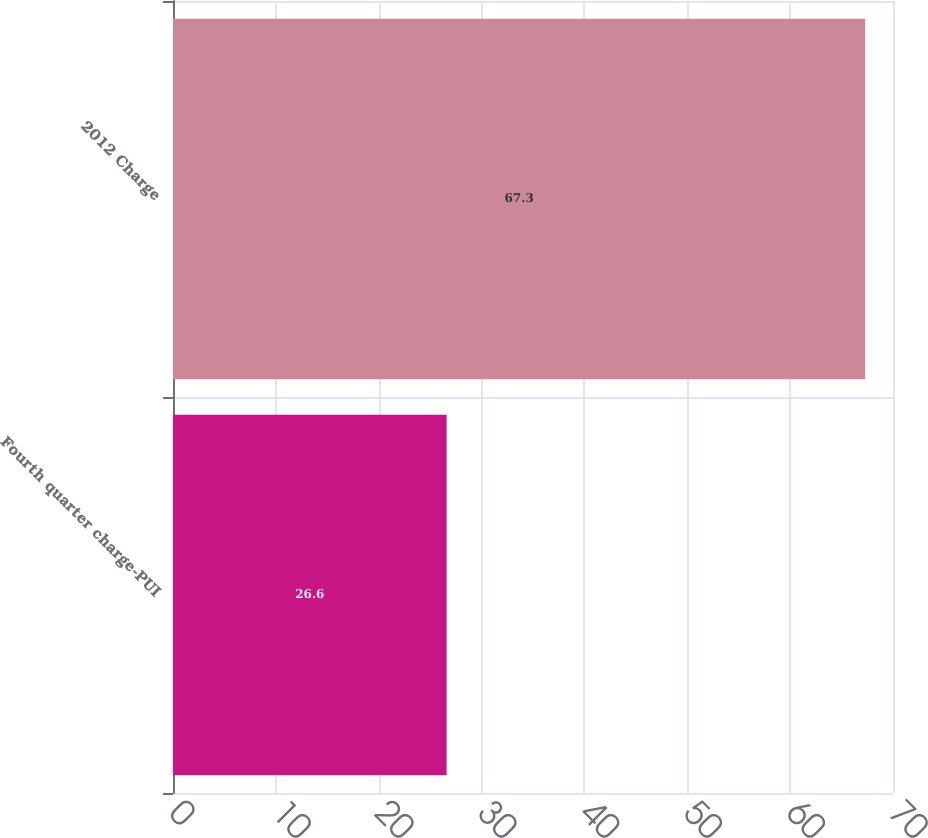<chart> <loc_0><loc_0><loc_500><loc_500><bar_chart><fcel>Fourth quarter charge-PUI<fcel>2012 Charge<nl><fcel>26.6<fcel>67.3<nl></chart> 